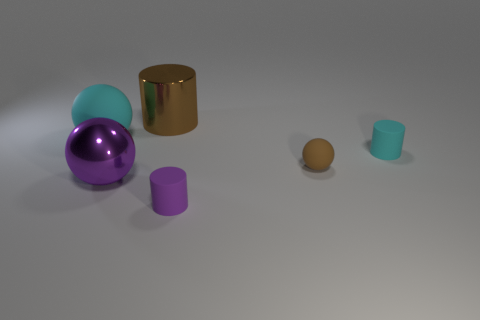What is the size of the cyan thing that is the same shape as the brown metallic thing?
Your answer should be compact. Small. There is a tiny cyan thing; does it have the same shape as the purple shiny object that is to the left of the brown ball?
Provide a short and direct response. No. There is a matte object that is in front of the sphere that is in front of the brown rubber sphere; what is its size?
Keep it short and to the point. Small. Are there the same number of large brown metallic objects to the right of the tiny matte sphere and shiny cylinders left of the cyan matte ball?
Make the answer very short. Yes. There is a big rubber object that is the same shape as the small brown rubber thing; what is its color?
Your response must be concise. Cyan. How many tiny matte objects have the same color as the big rubber ball?
Your response must be concise. 1. There is a metal thing that is to the right of the large metal ball; does it have the same shape as the tiny purple rubber object?
Ensure brevity in your answer.  Yes. What shape is the cyan rubber object that is right of the small matte cylinder that is in front of the big metal object to the left of the big brown metallic thing?
Your response must be concise. Cylinder. The purple ball has what size?
Your answer should be very brief. Large. The other object that is made of the same material as the large purple thing is what color?
Your answer should be compact. Brown. 